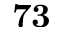Convert formula to latex. <formula><loc_0><loc_0><loc_500><loc_500>7 3</formula> 